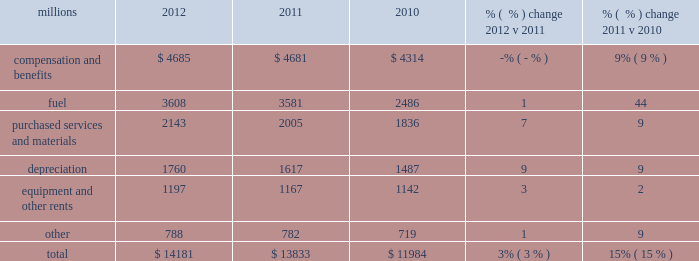Operating expenses millions 2012 2011 2010 % (  % ) change 2012 v 2011 % (  % ) change 2011 v 2010 .
Operating expenses increased $ 348 million in 2012 versus 2011 .
Depreciation , wage and benefit inflation , higher fuel prices and volume- related trucking services purchased by our logistics subsidiaries , contributed to higher expenses during the year .
Efficiency gains , volume related fuel savings ( 2% ( 2 % ) fewer gallons of fuel consumed ) and $ 38 million of weather related expenses in 2011 , which favorably affects the comparison , partially offset the cost increase .
Operating expenses increased $ 1.8 billion in 2011 versus 2010 .
Our fuel price per gallon rose 36% ( 36 % ) during 2011 , accounting for $ 922 million of the increase .
Wage and benefit inflation , volume-related costs , depreciation , and property taxes also contributed to higher expenses .
Expenses increased $ 20 million for costs related to the flooding in the midwest and $ 18 million due to the impact of severe heat and drought in the south , primarily texas .
Cost savings from productivity improvements and better resource utilization partially offset these increases .
A $ 45 million one-time payment relating to a transaction with csx intermodal , inc ( csxi ) increased operating expenses during the first quarter of 2010 , which favorably affects the comparison of operating expenses in 2011 to those in 2010 .
Compensation and benefits 2013 compensation and benefits include wages , payroll taxes , health and welfare costs , pension costs , other postretirement benefits , and incentive costs .
Expenses in 2012 were essentially flat versus 2011 as operational improvements and cost reductions offset general wage and benefit inflation and higher pension and other postretirement benefits .
In addition , weather related costs increased these expenses in 2011 .
A combination of general wage and benefit inflation , volume-related expenses , higher training costs associated with new hires , additional crew costs due to speed restrictions caused by the midwest flooding and heat and drought in the south , and higher pension expense drove the increase during 2011 compared to 2010 .
Fuel 2013 fuel includes locomotive fuel and gasoline for highway and non-highway vehicles and heavy equipment .
Higher locomotive diesel fuel prices , which averaged $ 3.22 per gallon ( including taxes and transportation costs ) in 2012 , compared to $ 3.12 in 2011 , increased expenses by $ 105 million .
Volume , as measured by gross ton-miles , decreased 2% ( 2 % ) in 2012 versus 2011 , driving expense down .
The fuel consumption rate was flat year-over-year .
Higher locomotive diesel fuel prices , which averaged $ 3.12 ( including taxes and transportation costs ) in 2011 , compared to $ 2.29 per gallon in 2010 , increased expenses by $ 922 million .
In addition , higher gasoline prices for highway and non-highway vehicles also increased year-over-year .
Volume , as measured by gross ton-miles , increased 5% ( 5 % ) in 2011 versus 2010 , driving expense up by $ 122 million .
Purchased services and materials 2013 expense for purchased services and materials includes the costs of services purchased from outside contractors and other service providers ( including equipment 2012 operating expenses .
What percentage of total operating expenses was purchased services and materials in 2011? 
Computations: (2005 / 13833)
Answer: 0.14494. 